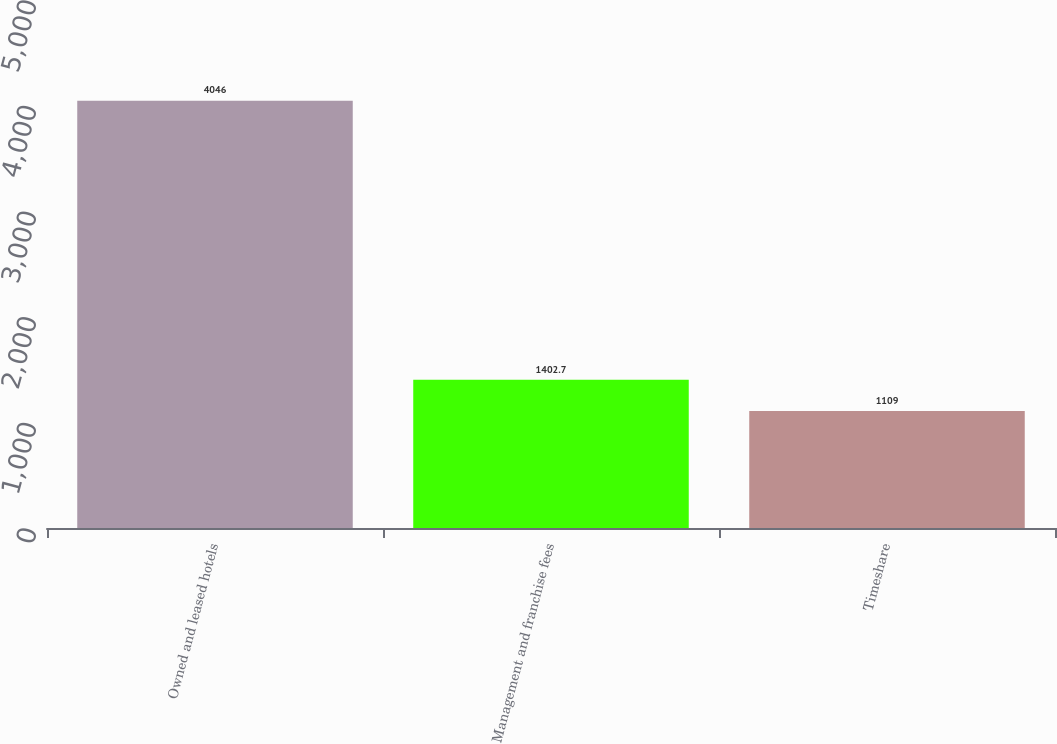Convert chart. <chart><loc_0><loc_0><loc_500><loc_500><bar_chart><fcel>Owned and leased hotels<fcel>Management and franchise fees<fcel>Timeshare<nl><fcel>4046<fcel>1402.7<fcel>1109<nl></chart> 